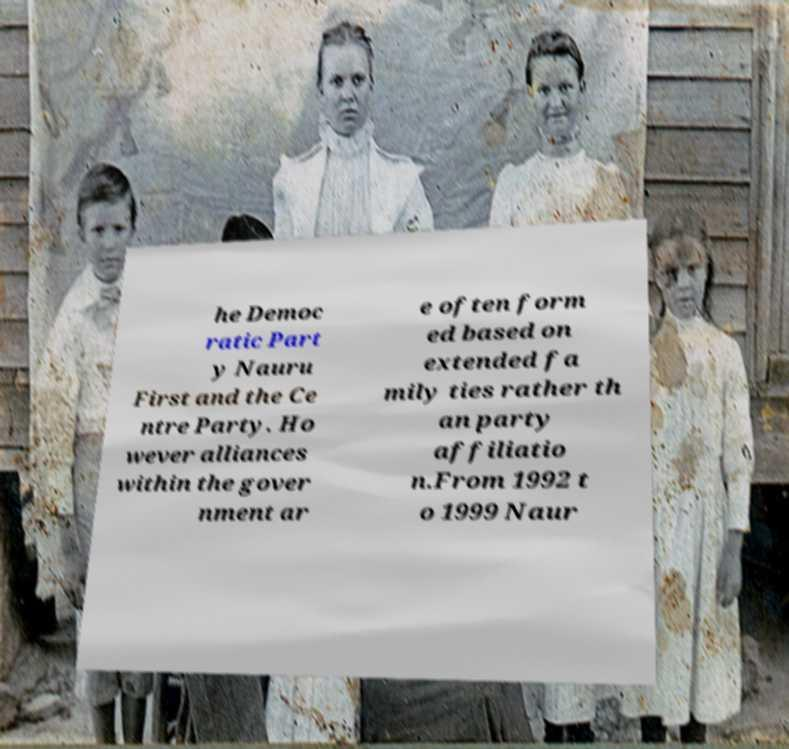Please identify and transcribe the text found in this image. he Democ ratic Part y Nauru First and the Ce ntre Party. Ho wever alliances within the gover nment ar e often form ed based on extended fa mily ties rather th an party affiliatio n.From 1992 t o 1999 Naur 